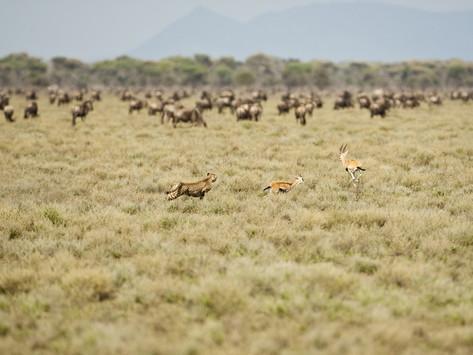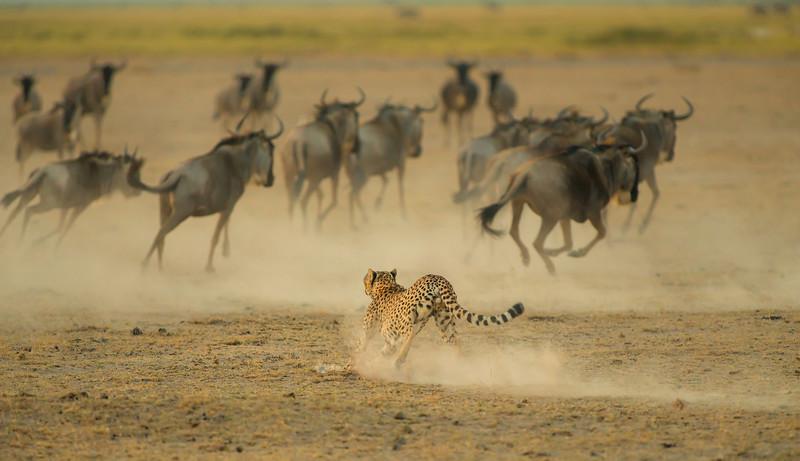The first image is the image on the left, the second image is the image on the right. For the images displayed, is the sentence "An image shows a back-turned cheetah running toward a herd of fleeing horned animals, which are kicking up clouds of dust." factually correct? Answer yes or no. Yes. The first image is the image on the left, the second image is the image on the right. Given the left and right images, does the statement "Both images show a cheetah chasing potential prey." hold true? Answer yes or no. Yes. 